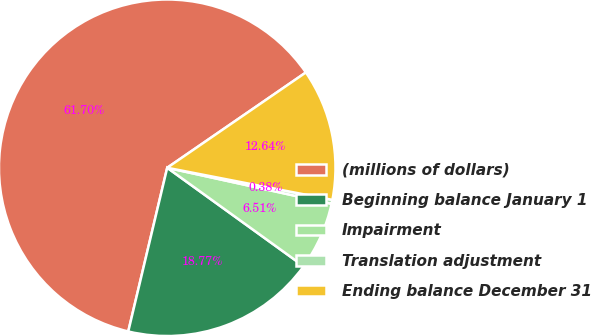<chart> <loc_0><loc_0><loc_500><loc_500><pie_chart><fcel>(millions of dollars)<fcel>Beginning balance January 1<fcel>Impairment<fcel>Translation adjustment<fcel>Ending balance December 31<nl><fcel>61.69%<fcel>18.77%<fcel>6.51%<fcel>0.38%<fcel>12.64%<nl></chart> 